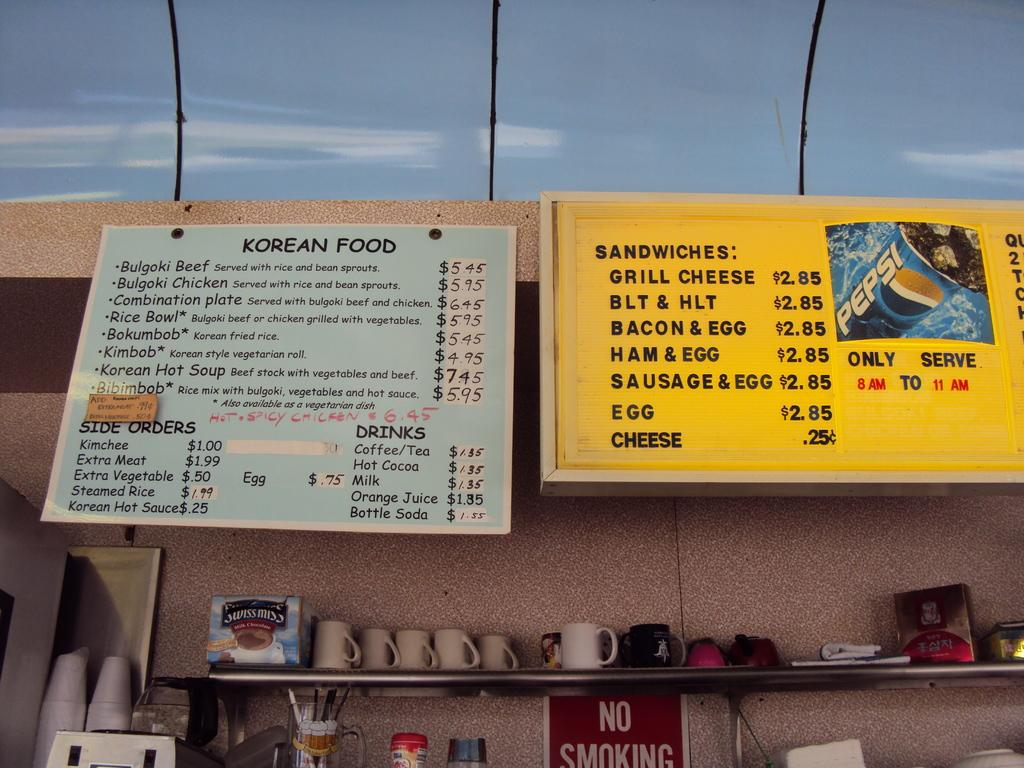<image>
Provide a brief description of the given image. Restaurant with a red sign that says No Smoking. 